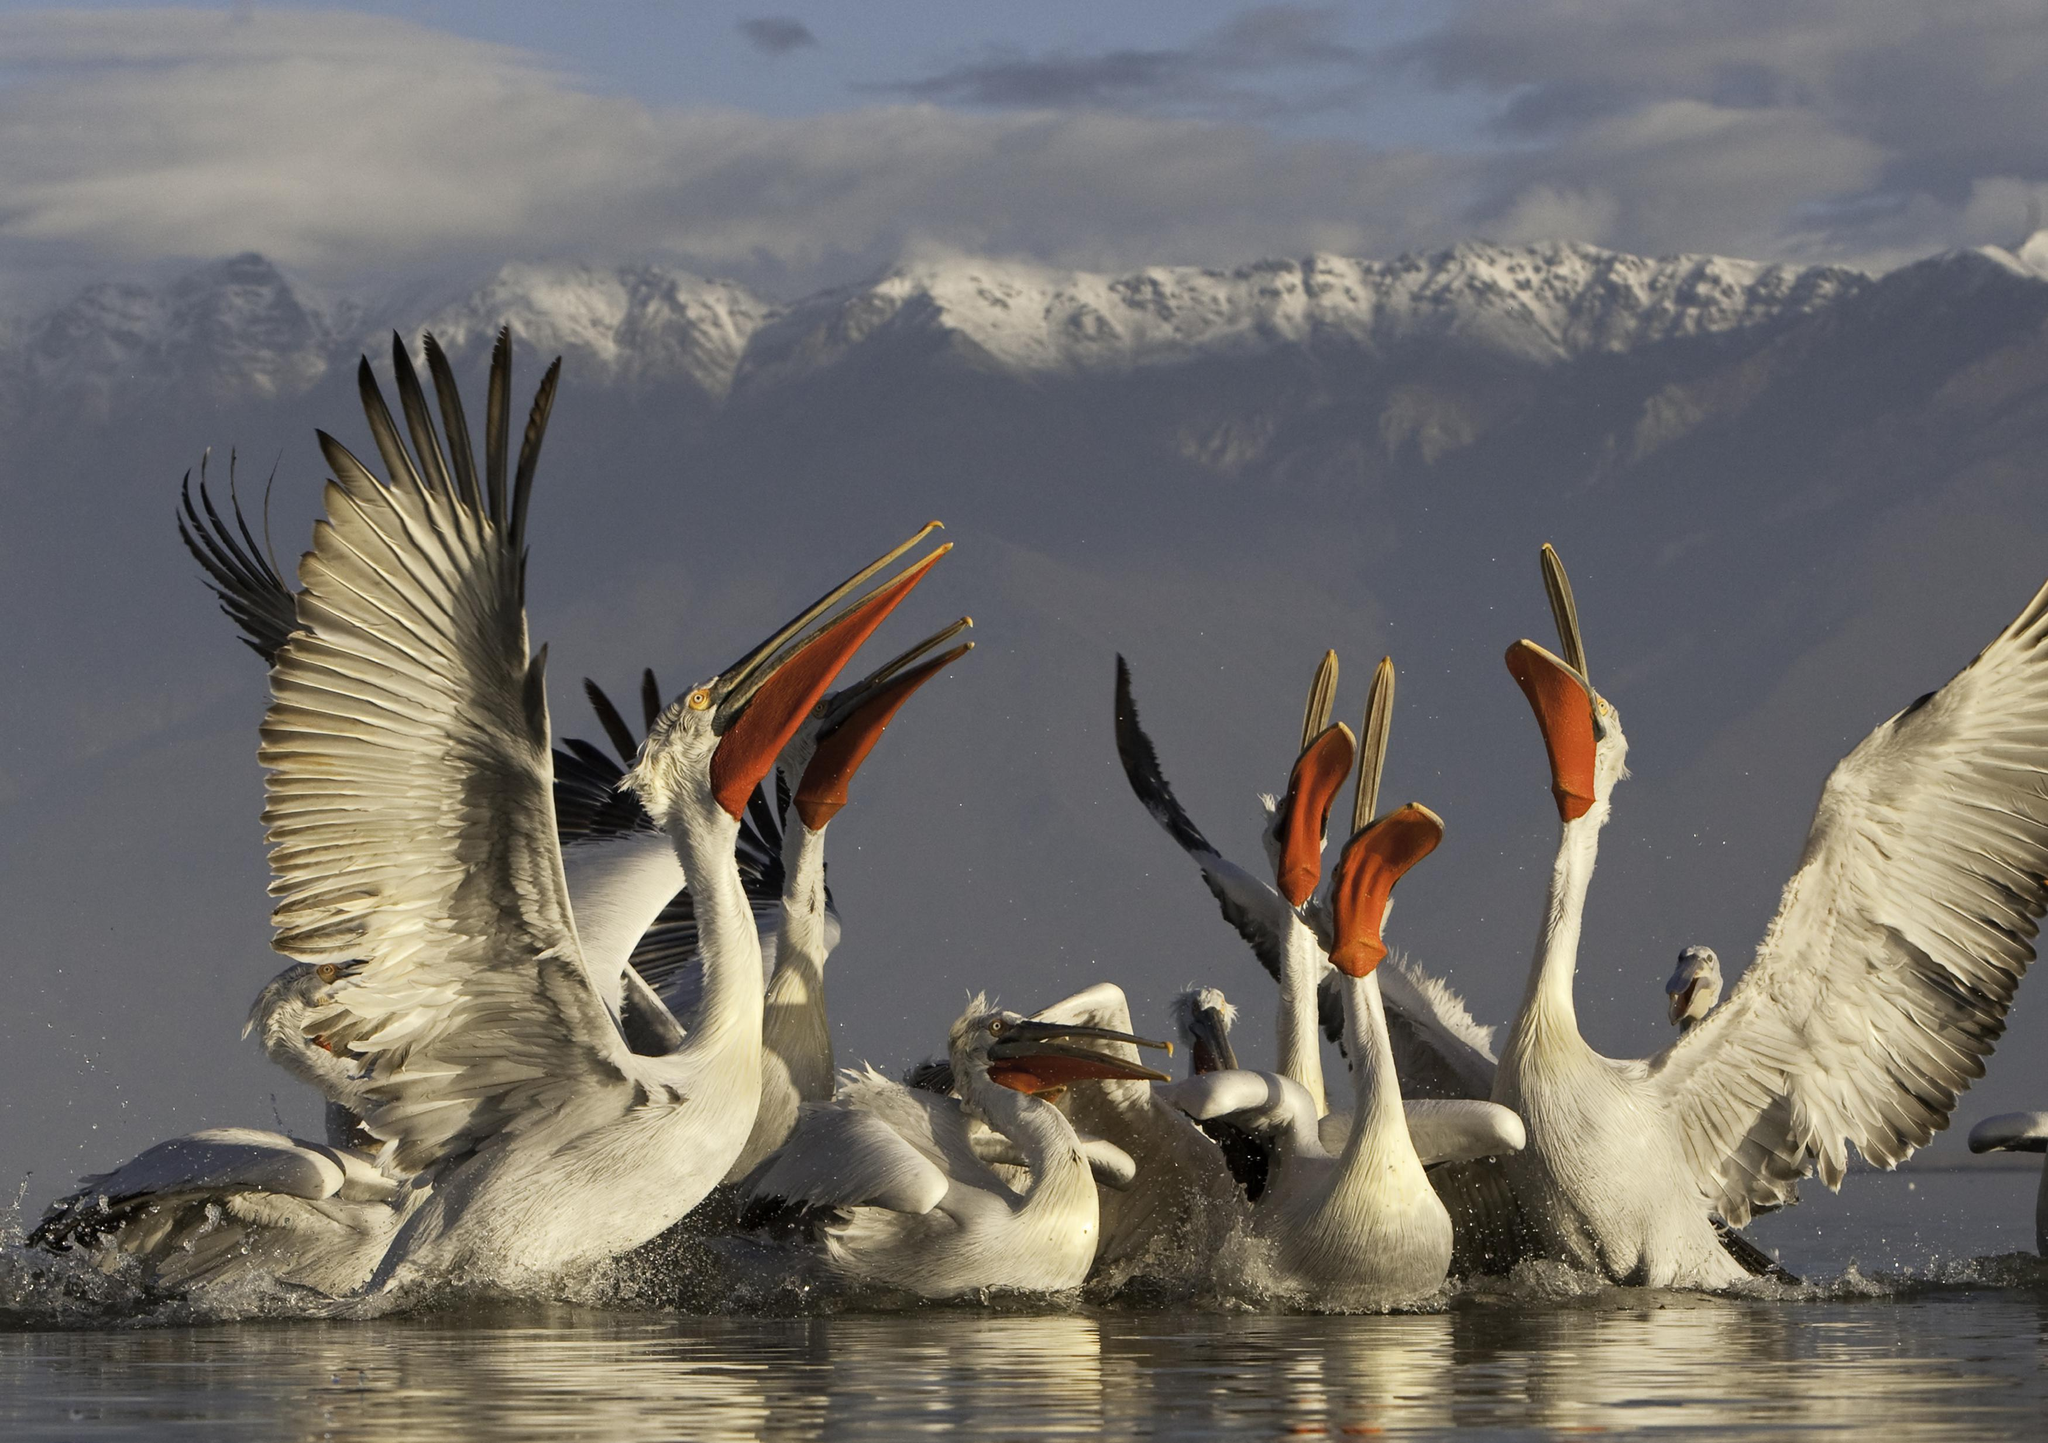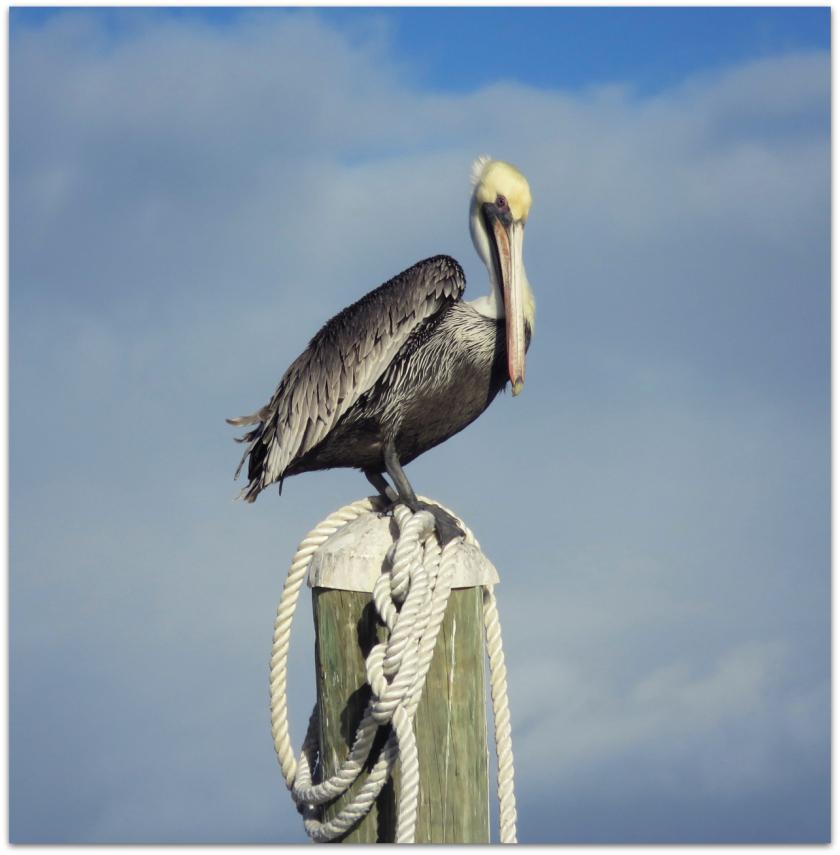The first image is the image on the left, the second image is the image on the right. Given the left and right images, does the statement "There is at least one image of one or more pelicans standing on a dock." hold true? Answer yes or no. No. The first image is the image on the left, the second image is the image on the right. Evaluate the accuracy of this statement regarding the images: "There is an animal directly on top of a wooden post.". Is it true? Answer yes or no. Yes. 